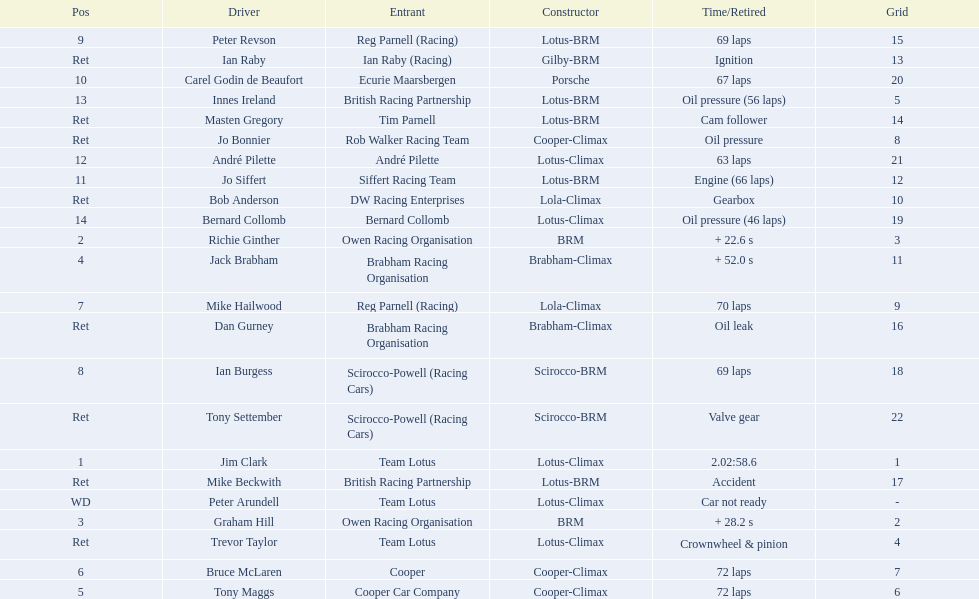What are the listed driver names? Jim Clark, Richie Ginther, Graham Hill, Jack Brabham, Tony Maggs, Bruce McLaren, Mike Hailwood, Ian Burgess, Peter Revson, Carel Godin de Beaufort, Jo Siffert, André Pilette, Innes Ireland, Bernard Collomb, Ian Raby, Dan Gurney, Mike Beckwith, Masten Gregory, Trevor Taylor, Jo Bonnier, Tony Settember, Bob Anderson, Peter Arundell. Which are tony maggs and jo siffert? Tony Maggs, Jo Siffert. What are their corresponding finishing places? 5, 11. Whose is better? Tony Maggs. 